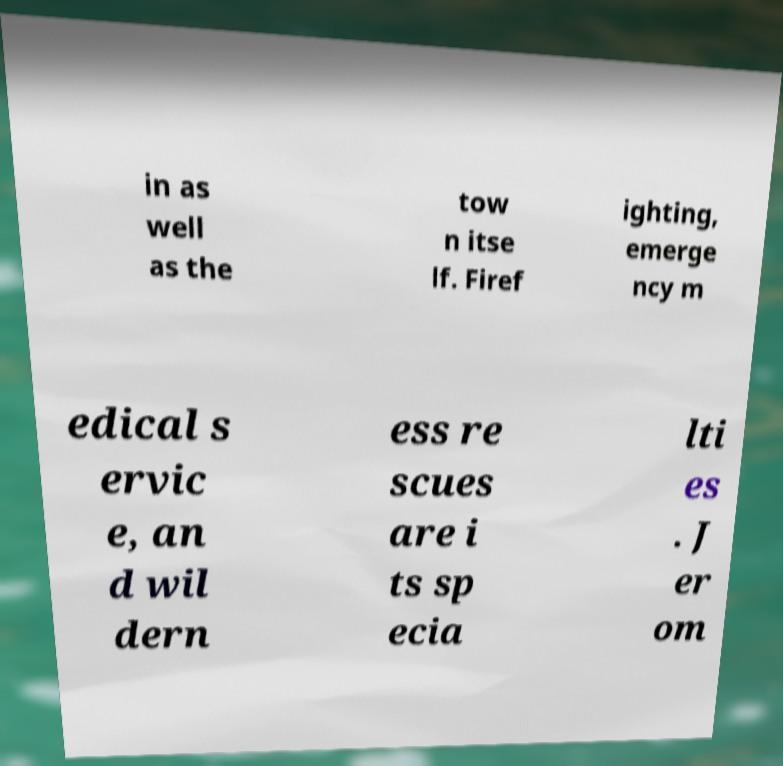Please read and relay the text visible in this image. What does it say? in as well as the tow n itse lf. Firef ighting, emerge ncy m edical s ervic e, an d wil dern ess re scues are i ts sp ecia lti es . J er om 